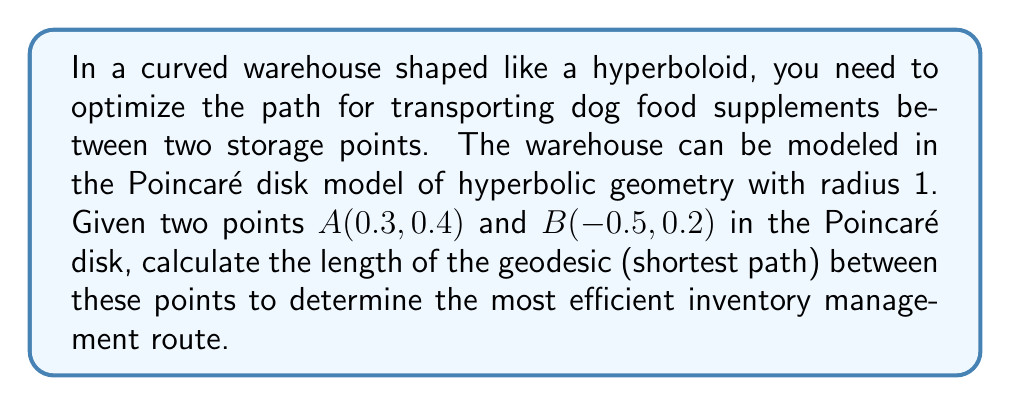Could you help me with this problem? To solve this problem, we'll follow these steps:

1) In the Poincaré disk model, the geodesic between two points is either an arc of a circle orthogonal to the boundary of the disk or a diameter of the disk.

2) We can determine if the geodesic is a diameter by checking if the points and the origin are collinear. In this case, they are not, so we're dealing with an arc.

3) The formula for the hyperbolic distance $d$ between two points $(x_1, y_1)$ and $(x_2, y_2)$ in the Poincaré disk model is:

   $$d = \text{arcosh}\left(1 + \frac{2(x_1-x_2)^2 + 2(y_1-y_2)^2}{(1-x_1^2-y_1^2)(1-x_2^2-y_2^2)}\right)$$

4) Let's substitute our values:
   $(x_1, y_1) = (0.3, 0.4)$ and $(x_2, y_2) = (-0.5, 0.2)$

5) Calculate the numerator:
   $2(x_1-x_2)^2 + 2(y_1-y_2)^2 = 2(0.3-(-0.5))^2 + 2(0.4-0.2)^2 = 2(0.8)^2 + 2(0.2)^2 = 1.36$

6) Calculate the denominator:
   $(1-x_1^2-y_1^2)(1-x_2^2-y_2^2) = (1-0.3^2-0.4^2)(1-(-0.5)^2-0.2^2) = (0.75)(0.71) = 0.5325$

7) Substitute into the formula:
   $$d = \text{arcosh}\left(1 + \frac{1.36}{0.5325}\right) = \text{arcosh}(3.5545)$$

8) Calculate the final result:
   $$d \approx 1.9794$$

This value represents the length of the geodesic in the hyperbolic space of the warehouse.

[asy]
import geometry;

unitsize(100);
draw(circle((0,0),1));
dot((0.3,0.4),red);
dot((-0.5,0.2),red);
label("A",(0.3,0.4),NE);
label("B",(-0.5,0.2),NW);

pair A = (0.3,0.4);
pair B = (-0.5,0.2);
pair O = (0,0);

pair C = circumcenter(A,B,O);
real r = abs(C-A);

draw(arc(C,r,degrees(A-C),degrees(B-C)));
[/asy]
Answer: $1.9794$ 